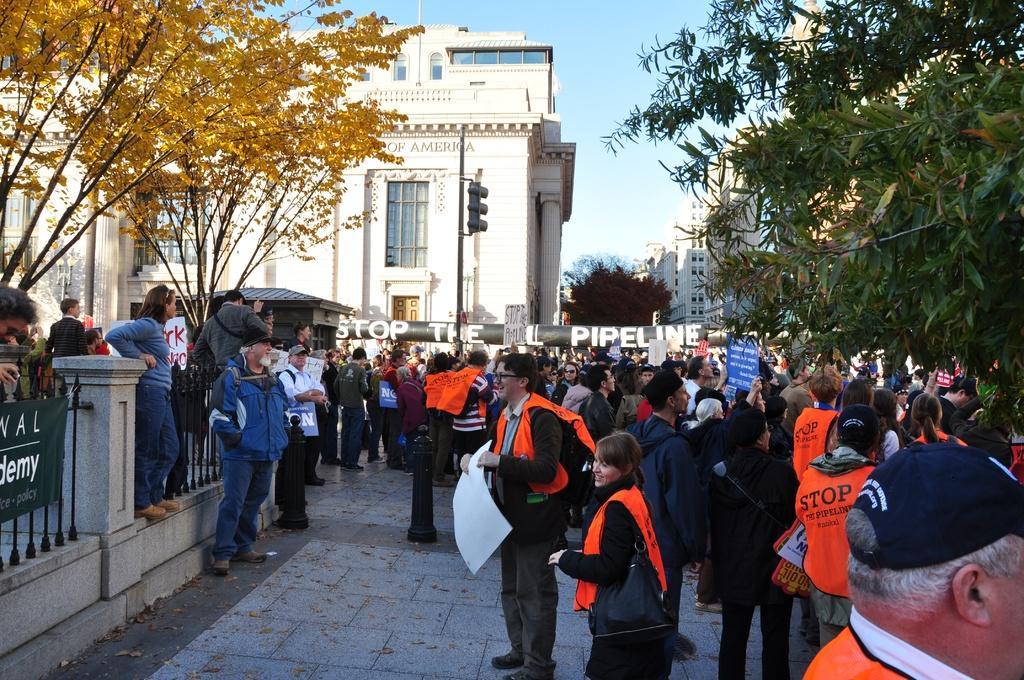Can you describe this image briefly? In this picture we can see a group of people standing and some people holding the boards. On the left side of the people there is a banner and iron grilles. Behind the people, there is a pipeline, buildings, trees and a pole with traffic signals. Behind the buildings there is the sky. 